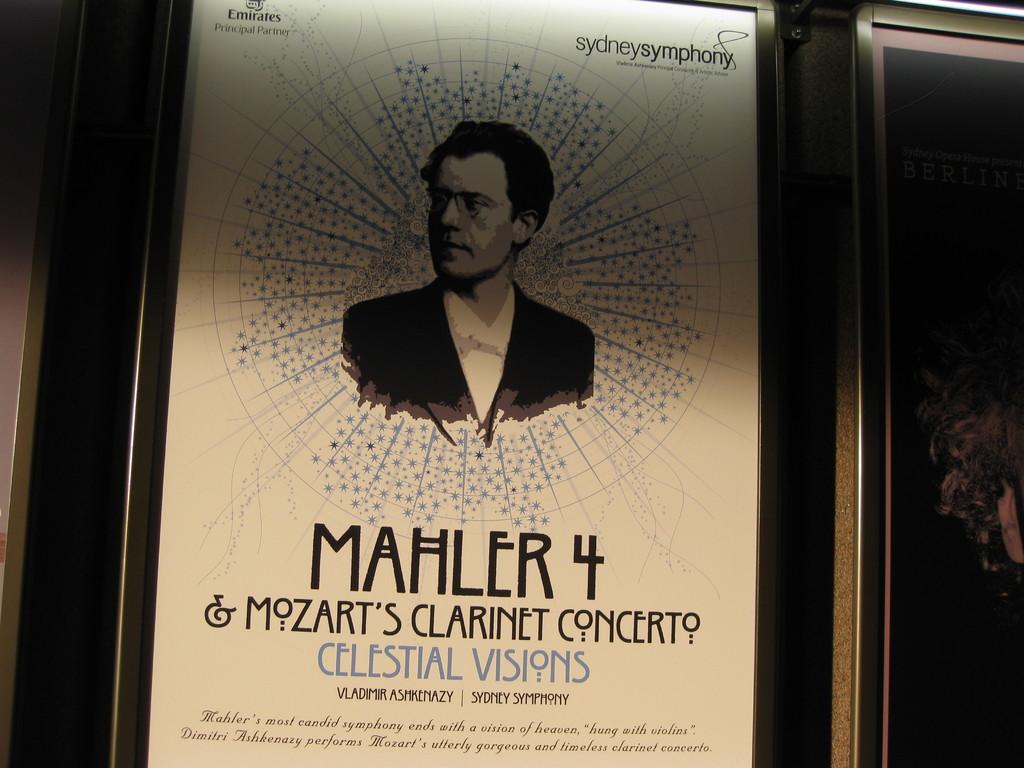What composer is listed next to the number 4?
Provide a short and direct response. Mahler. 